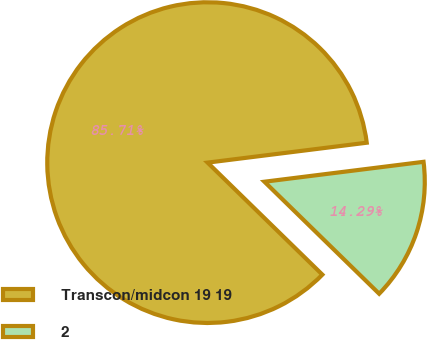Convert chart to OTSL. <chart><loc_0><loc_0><loc_500><loc_500><pie_chart><fcel>Transcon/midcon 19 19<fcel>2<nl><fcel>85.71%<fcel>14.29%<nl></chart> 